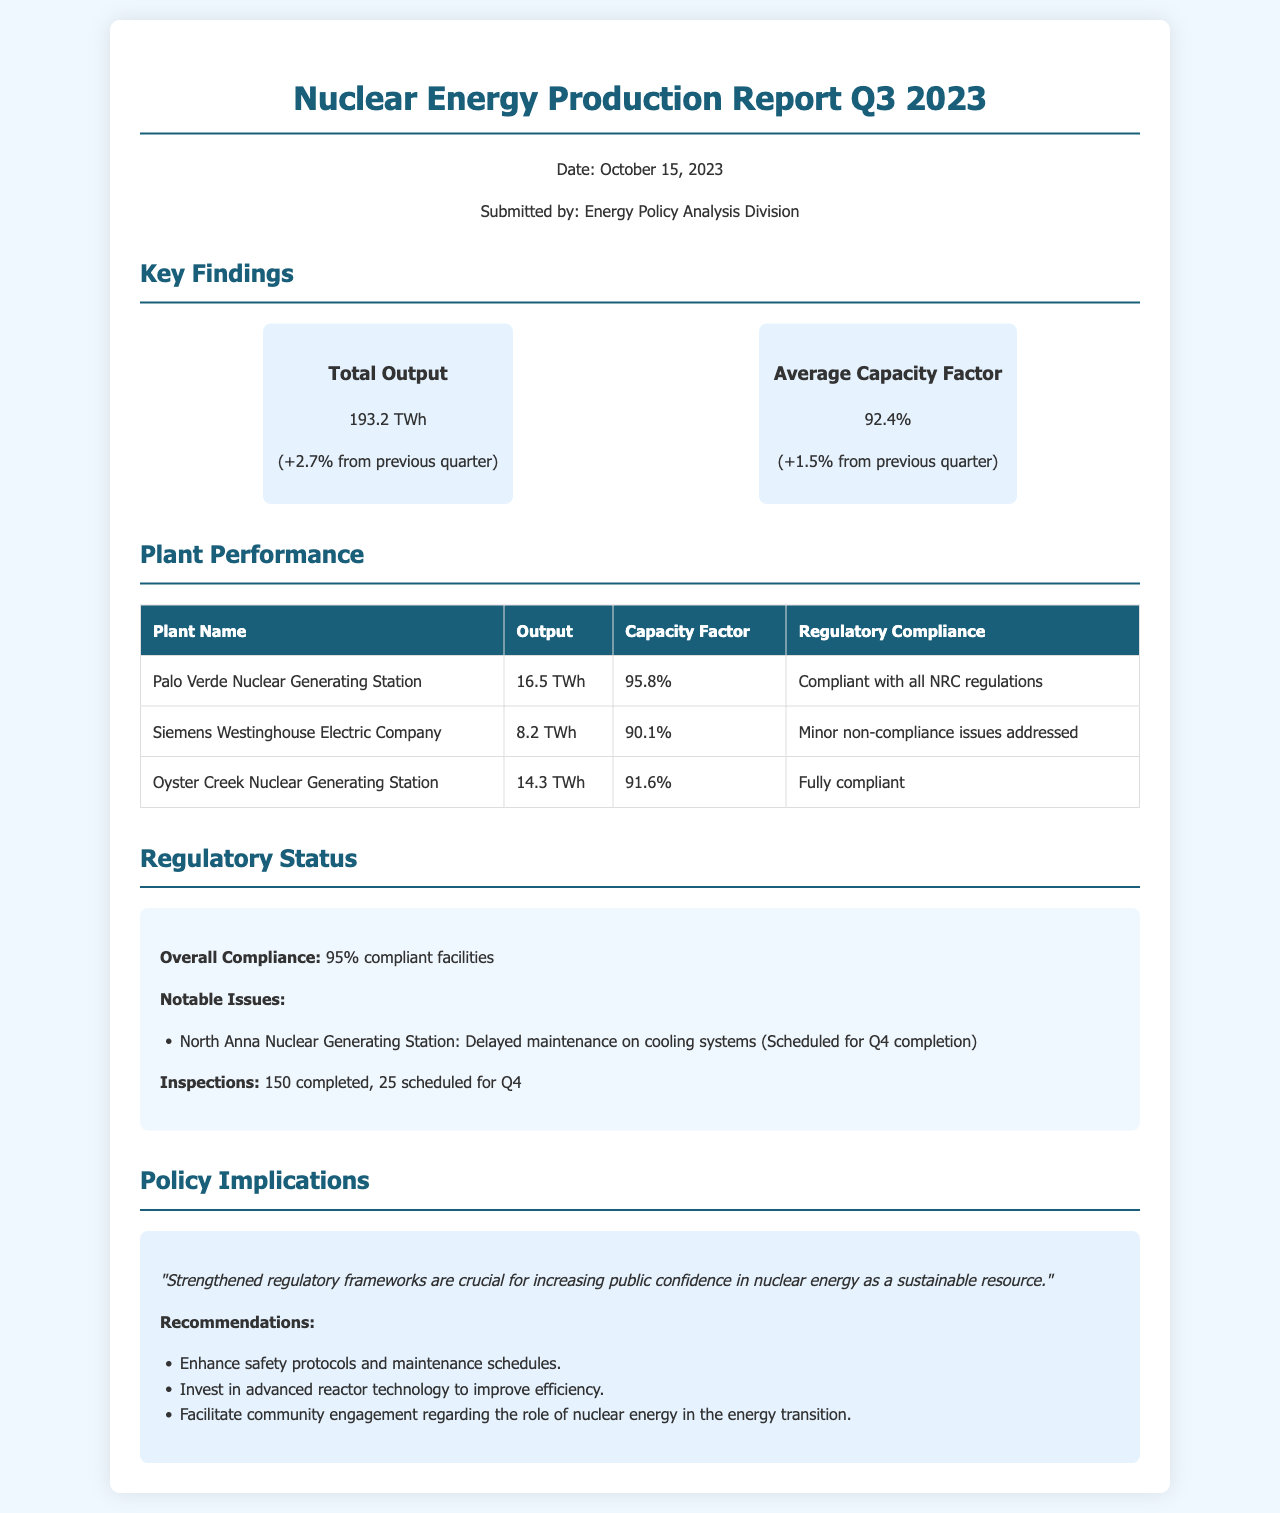What was the total output for Q3 2023? The total output for Q3 2023 is stated as 193.2 TWh, indicating the amount of energy produced during this period.
Answer: 193.2 TWh What is the average capacity factor for Q3 2023? The document provides the average capacity factor as a percentage, which is relevant for understanding operational efficiency.
Answer: 92.4% Which plant had the highest output? The table lists plant outputs, allowing for a comparison to identify which facility produced the most energy.
Answer: Palo Verde Nuclear Generating Station What compliance status did the Siemens Westinghouse Electric Company report? Analyzing the compliance status helps understand each facility's regulatory standing, with specific situations detailed.
Answer: Minor non-compliance issues addressed What percentage of facilities are compliant overall? This percentage reflects the general compliance status of the nuclear facilities, which is important for regulatory oversight.
Answer: 95% What notable issue was reported for North Anna Nuclear Generating Station? Identifying specific issues provides insight into areas needing attention or improvement within nuclear facilities.
Answer: Delayed maintenance on cooling systems How many inspections were completed? The number of inspections completed indicates the level of oversight being exercised over nuclear facilities in Q3.
Answer: 150 What is one of the recommendations made in the policy implications section? Reviewing the recommendations allows for a deeper understanding of how to enhance nuclear energy's role in sustainability.
Answer: Enhance safety protocols and maintenance schedules What date was the report submitted? The submission date adds context to the relevance and timeliness of the information presented in the report.
Answer: October 15, 2023 